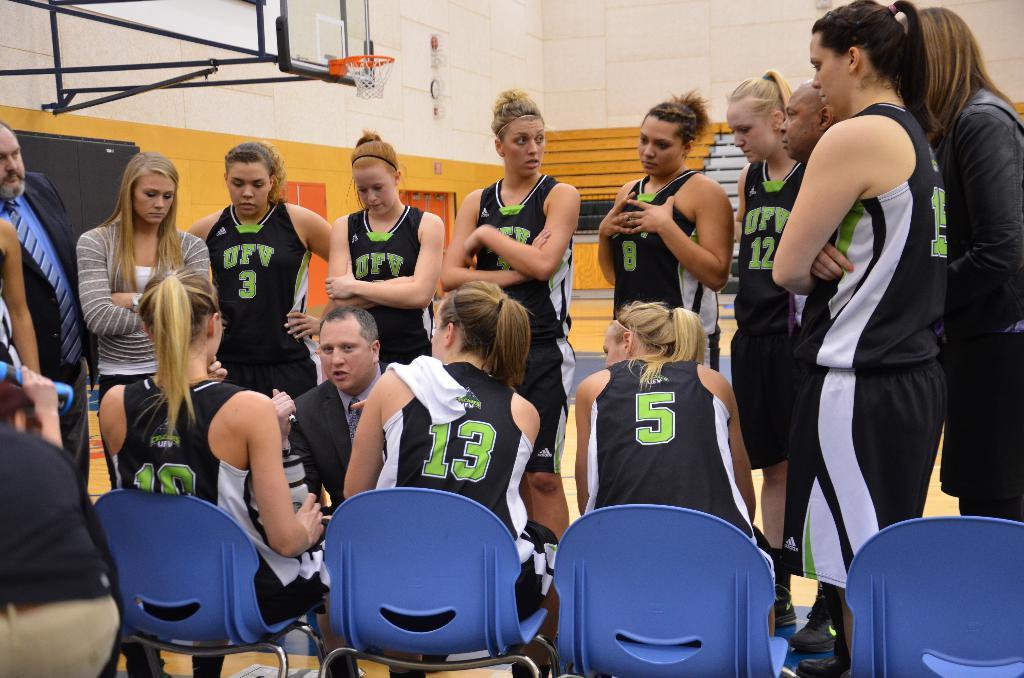Could you give a brief overview of what you see in this image? These are the 3 women sitting on the chair listening to the other person who is sitting opposite to them is wearing coat and few other people are standing at here. Behind them there is a wall and the top there is a basketball net. 